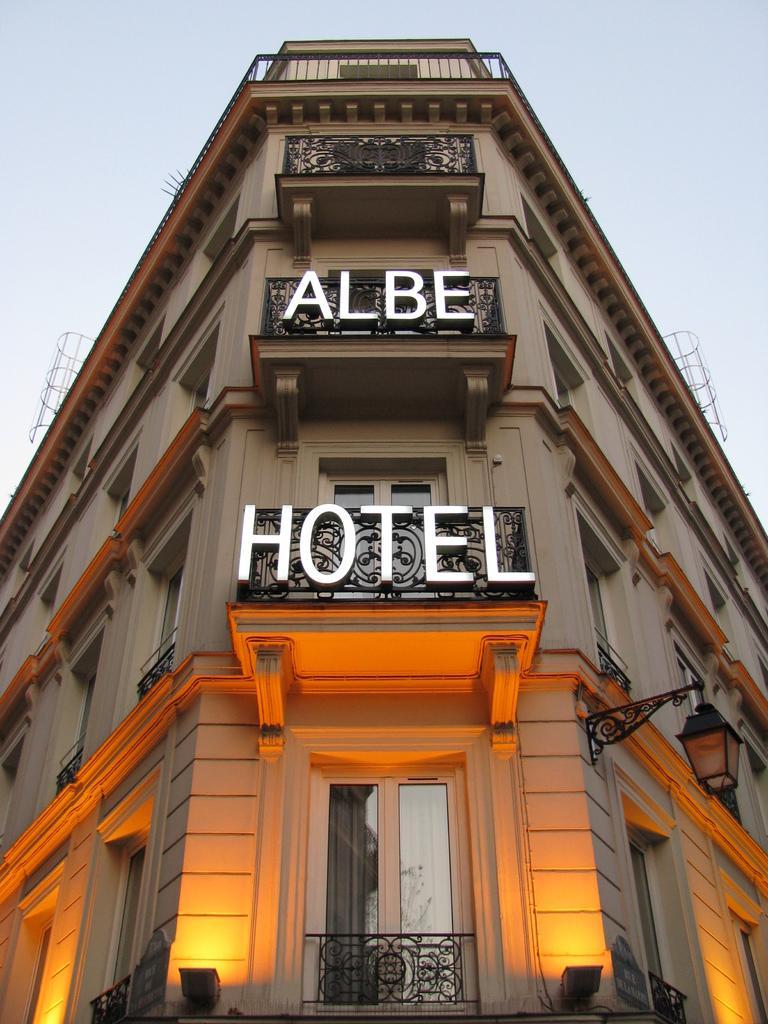How would you summarize this image in a sentence or two? In this image I can see a building which has a lamp, lights, windows and fence. ´´Albe hotel´ is written on it. 